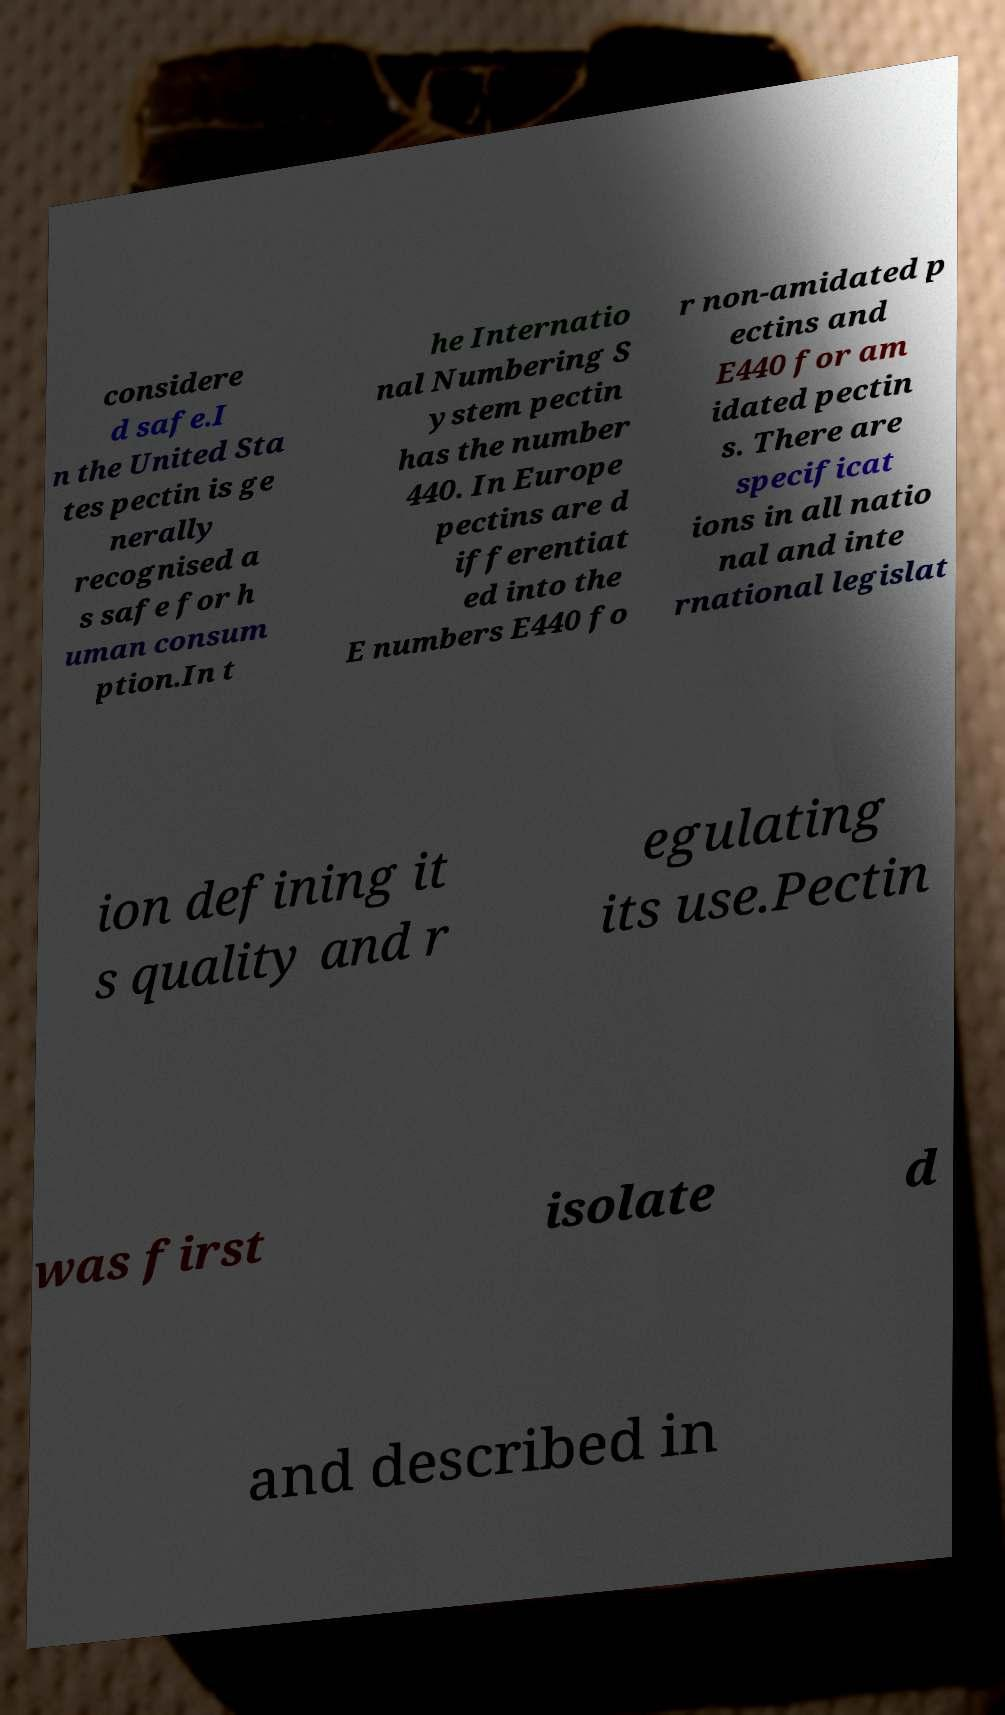Can you read and provide the text displayed in the image?This photo seems to have some interesting text. Can you extract and type it out for me? considere d safe.I n the United Sta tes pectin is ge nerally recognised a s safe for h uman consum ption.In t he Internatio nal Numbering S ystem pectin has the number 440. In Europe pectins are d ifferentiat ed into the E numbers E440 fo r non-amidated p ectins and E440 for am idated pectin s. There are specificat ions in all natio nal and inte rnational legislat ion defining it s quality and r egulating its use.Pectin was first isolate d and described in 